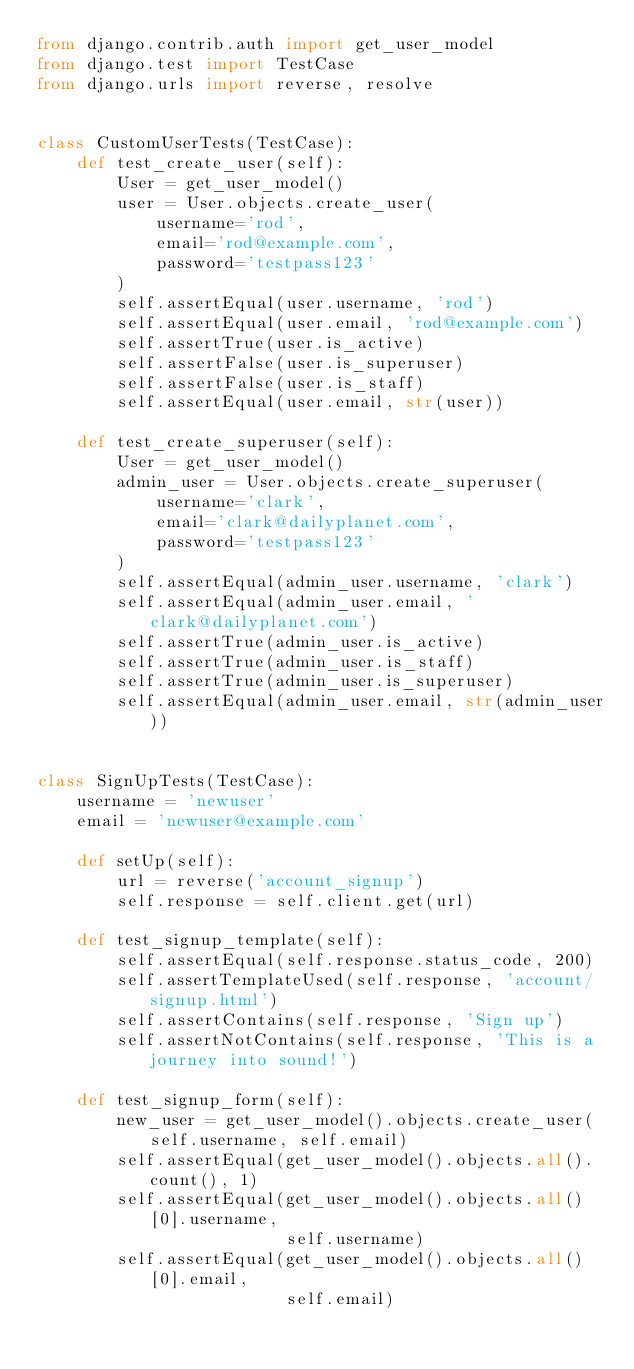Convert code to text. <code><loc_0><loc_0><loc_500><loc_500><_Python_>from django.contrib.auth import get_user_model
from django.test import TestCase
from django.urls import reverse, resolve


class CustomUserTests(TestCase):
    def test_create_user(self):
        User = get_user_model()
        user = User.objects.create_user(
            username='rod',
            email='rod@example.com',
            password='testpass123'
        )
        self.assertEqual(user.username, 'rod')
        self.assertEqual(user.email, 'rod@example.com')
        self.assertTrue(user.is_active)
        self.assertFalse(user.is_superuser)
        self.assertFalse(user.is_staff)
        self.assertEqual(user.email, str(user))

    def test_create_superuser(self):
        User = get_user_model()
        admin_user = User.objects.create_superuser(
            username='clark',
            email='clark@dailyplanet.com',
            password='testpass123'
        )
        self.assertEqual(admin_user.username, 'clark')
        self.assertEqual(admin_user.email, 'clark@dailyplanet.com')
        self.assertTrue(admin_user.is_active)
        self.assertTrue(admin_user.is_staff)
        self.assertTrue(admin_user.is_superuser)
        self.assertEqual(admin_user.email, str(admin_user))


class SignUpTests(TestCase):
    username = 'newuser'
    email = 'newuser@example.com'

    def setUp(self):
        url = reverse('account_signup')
        self.response = self.client.get(url)

    def test_signup_template(self):
        self.assertEqual(self.response.status_code, 200)
        self.assertTemplateUsed(self.response, 'account/signup.html')
        self.assertContains(self.response, 'Sign up')
        self.assertNotContains(self.response, 'This is a journey into sound!')

    def test_signup_form(self):
        new_user = get_user_model().objects.create_user(self.username, self.email)
        self.assertEqual(get_user_model().objects.all().count(), 1)
        self.assertEqual(get_user_model().objects.all()[0].username,
                         self.username)
        self.assertEqual(get_user_model().objects.all()[0].email,
                         self.email)
</code> 